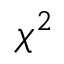<formula> <loc_0><loc_0><loc_500><loc_500>\chi ^ { 2 }</formula> 